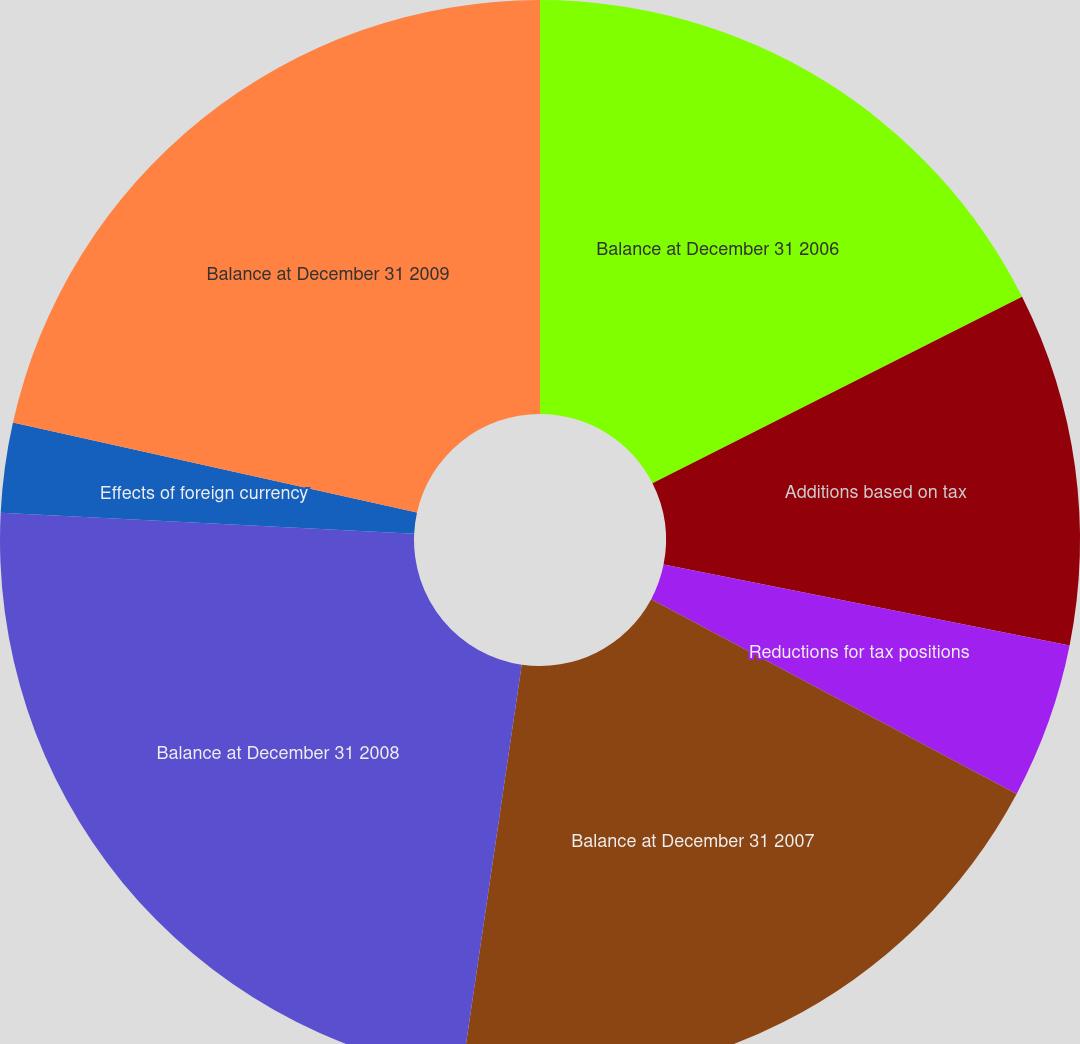Convert chart to OTSL. <chart><loc_0><loc_0><loc_500><loc_500><pie_chart><fcel>Balance at December 31 2006<fcel>Additions based on tax<fcel>Reductions for tax positions<fcel>Balance at December 31 2007<fcel>Balance at December 31 2008<fcel>Effects of foreign currency<fcel>Balance at December 31 2009<nl><fcel>17.56%<fcel>10.57%<fcel>4.66%<fcel>19.53%<fcel>23.48%<fcel>2.69%<fcel>21.51%<nl></chart> 